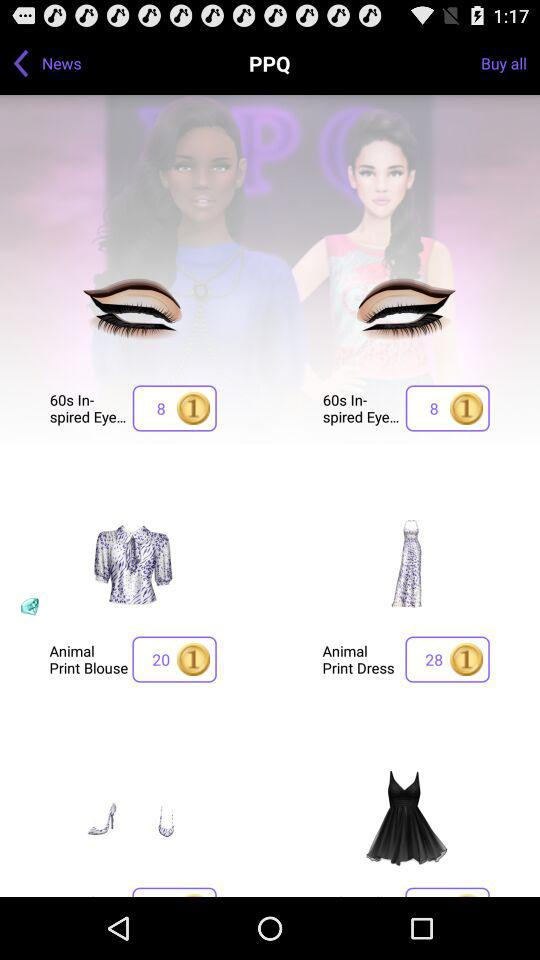What is the count of points for "Animal Print Dress"? The count is 28. 